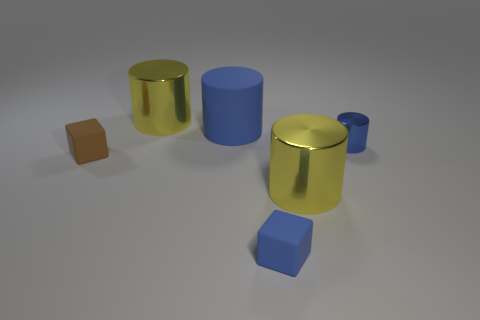How big is the yellow metal object on the left side of the big yellow thing in front of the tiny blue metal thing? The yellow metal object on the left appears to be a medium-sized cylindrical shape, roughly half the height of the large yellow cylinder it is beside and somewhat wider than the tiny blue cylinder in the foreground. 